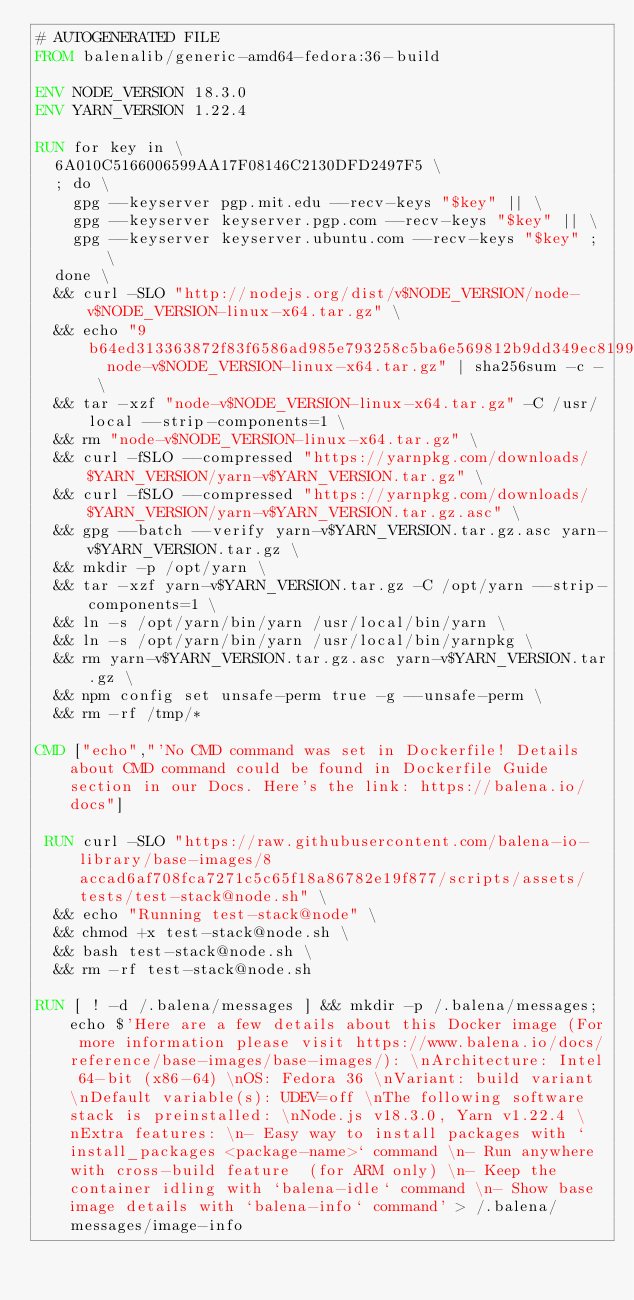<code> <loc_0><loc_0><loc_500><loc_500><_Dockerfile_># AUTOGENERATED FILE
FROM balenalib/generic-amd64-fedora:36-build

ENV NODE_VERSION 18.3.0
ENV YARN_VERSION 1.22.4

RUN for key in \
	6A010C5166006599AA17F08146C2130DFD2497F5 \
	; do \
		gpg --keyserver pgp.mit.edu --recv-keys "$key" || \
		gpg --keyserver keyserver.pgp.com --recv-keys "$key" || \
		gpg --keyserver keyserver.ubuntu.com --recv-keys "$key" ; \
	done \
	&& curl -SLO "http://nodejs.org/dist/v$NODE_VERSION/node-v$NODE_VERSION-linux-x64.tar.gz" \
	&& echo "9b64ed313363872f83f6586ad985e793258c5ba6e569812b9dd349ec819956cf  node-v$NODE_VERSION-linux-x64.tar.gz" | sha256sum -c - \
	&& tar -xzf "node-v$NODE_VERSION-linux-x64.tar.gz" -C /usr/local --strip-components=1 \
	&& rm "node-v$NODE_VERSION-linux-x64.tar.gz" \
	&& curl -fSLO --compressed "https://yarnpkg.com/downloads/$YARN_VERSION/yarn-v$YARN_VERSION.tar.gz" \
	&& curl -fSLO --compressed "https://yarnpkg.com/downloads/$YARN_VERSION/yarn-v$YARN_VERSION.tar.gz.asc" \
	&& gpg --batch --verify yarn-v$YARN_VERSION.tar.gz.asc yarn-v$YARN_VERSION.tar.gz \
	&& mkdir -p /opt/yarn \
	&& tar -xzf yarn-v$YARN_VERSION.tar.gz -C /opt/yarn --strip-components=1 \
	&& ln -s /opt/yarn/bin/yarn /usr/local/bin/yarn \
	&& ln -s /opt/yarn/bin/yarn /usr/local/bin/yarnpkg \
	&& rm yarn-v$YARN_VERSION.tar.gz.asc yarn-v$YARN_VERSION.tar.gz \
	&& npm config set unsafe-perm true -g --unsafe-perm \
	&& rm -rf /tmp/*

CMD ["echo","'No CMD command was set in Dockerfile! Details about CMD command could be found in Dockerfile Guide section in our Docs. Here's the link: https://balena.io/docs"]

 RUN curl -SLO "https://raw.githubusercontent.com/balena-io-library/base-images/8accad6af708fca7271c5c65f18a86782e19f877/scripts/assets/tests/test-stack@node.sh" \
  && echo "Running test-stack@node" \
  && chmod +x test-stack@node.sh \
  && bash test-stack@node.sh \
  && rm -rf test-stack@node.sh 

RUN [ ! -d /.balena/messages ] && mkdir -p /.balena/messages; echo $'Here are a few details about this Docker image (For more information please visit https://www.balena.io/docs/reference/base-images/base-images/): \nArchitecture: Intel 64-bit (x86-64) \nOS: Fedora 36 \nVariant: build variant \nDefault variable(s): UDEV=off \nThe following software stack is preinstalled: \nNode.js v18.3.0, Yarn v1.22.4 \nExtra features: \n- Easy way to install packages with `install_packages <package-name>` command \n- Run anywhere with cross-build feature  (for ARM only) \n- Keep the container idling with `balena-idle` command \n- Show base image details with `balena-info` command' > /.balena/messages/image-info</code> 